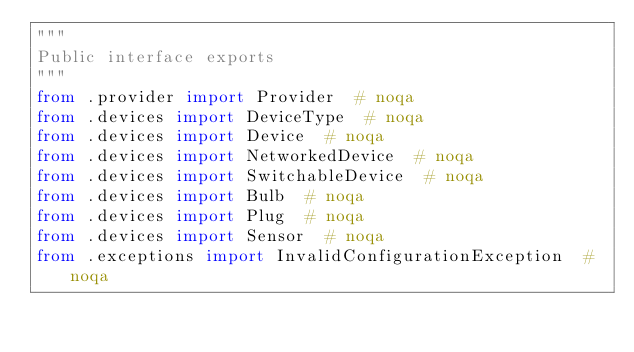Convert code to text. <code><loc_0><loc_0><loc_500><loc_500><_Python_>"""
Public interface exports
"""
from .provider import Provider  # noqa
from .devices import DeviceType  # noqa
from .devices import Device  # noqa
from .devices import NetworkedDevice  # noqa
from .devices import SwitchableDevice  # noqa
from .devices import Bulb  # noqa
from .devices import Plug  # noqa
from .devices import Sensor  # noqa
from .exceptions import InvalidConfigurationException  # noqa
</code> 